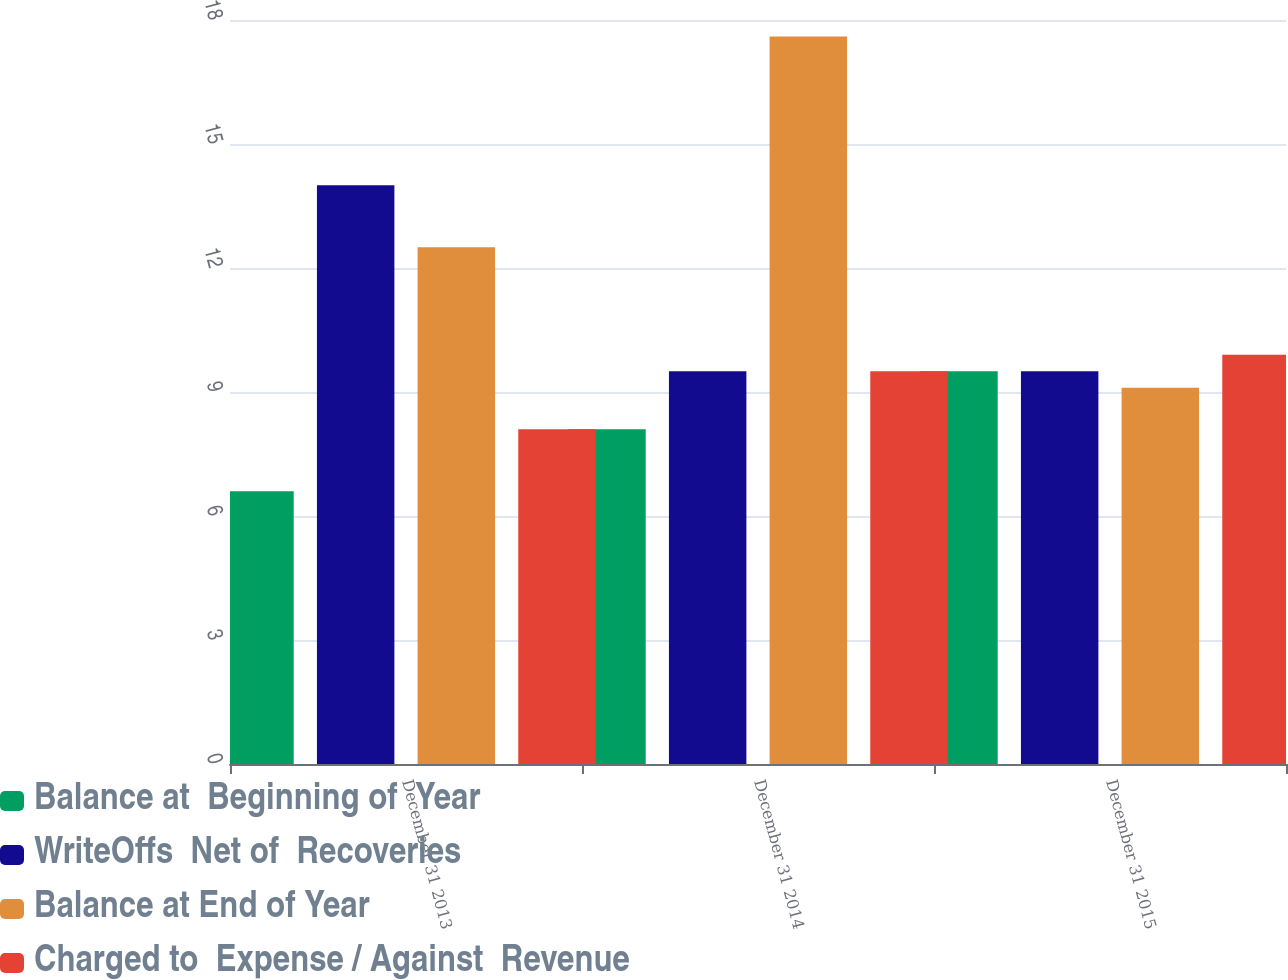Convert chart to OTSL. <chart><loc_0><loc_0><loc_500><loc_500><stacked_bar_chart><ecel><fcel>December 31 2013<fcel>December 31 2014<fcel>December 31 2015<nl><fcel>Balance at  Beginning of  Year<fcel>6.6<fcel>8.1<fcel>9.5<nl><fcel>WriteOffs  Net of  Recoveries<fcel>14<fcel>9.5<fcel>9.5<nl><fcel>Balance at End of Year<fcel>12.5<fcel>17.6<fcel>9.1<nl><fcel>Charged to  Expense / Against  Revenue<fcel>8.1<fcel>9.5<fcel>9.9<nl></chart> 